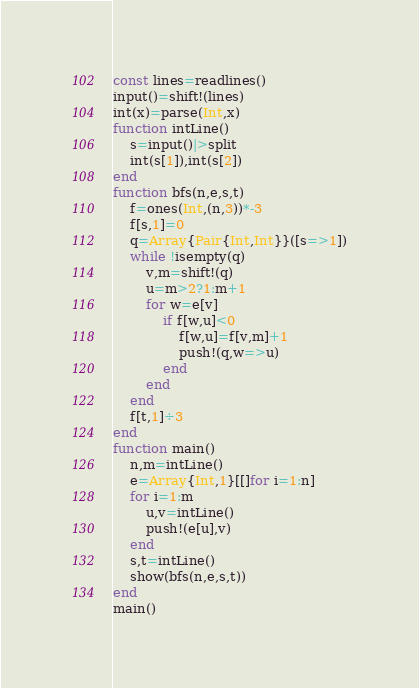Convert code to text. <code><loc_0><loc_0><loc_500><loc_500><_Julia_>const lines=readlines()
input()=shift!(lines)
int(x)=parse(Int,x)
function intLine()
    s=input()|>split
    int(s[1]),int(s[2])
end
function bfs(n,e,s,t)
    f=ones(Int,(n,3))*-3
    f[s,1]=0
    q=Array{Pair{Int,Int}}([s=>1])
    while !isempty(q)
        v,m=shift!(q)
        u=m>2?1:m+1
        for w=e[v]
            if f[w,u]<0
                f[w,u]=f[v,m]+1
                push!(q,w=>u)
            end
        end
    end
    f[t,1]÷3
end
function main()
    n,m=intLine()
    e=Array{Int,1}[[]for i=1:n]
    for i=1:m
        u,v=intLine()
        push!(e[u],v)
    end
    s,t=intLine()
    show(bfs(n,e,s,t))
end
main()</code> 